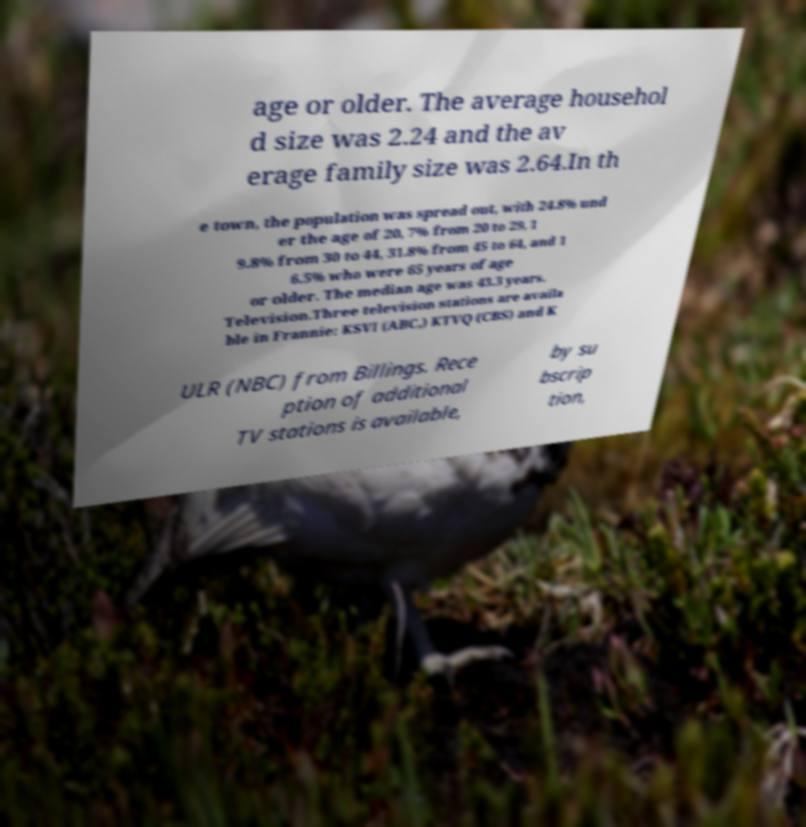What messages or text are displayed in this image? I need them in a readable, typed format. age or older. The average househol d size was 2.24 and the av erage family size was 2.64.In th e town, the population was spread out, with 24.8% und er the age of 20, 7% from 20 to 29, 1 9.8% from 30 to 44, 31.8% from 45 to 64, and 1 6.5% who were 65 years of age or older. The median age was 43.3 years. Television.Three television stations are availa ble in Frannie: KSVI (ABC,) KTVQ (CBS) and K ULR (NBC) from Billings. Rece ption of additional TV stations is available, by su bscrip tion, 